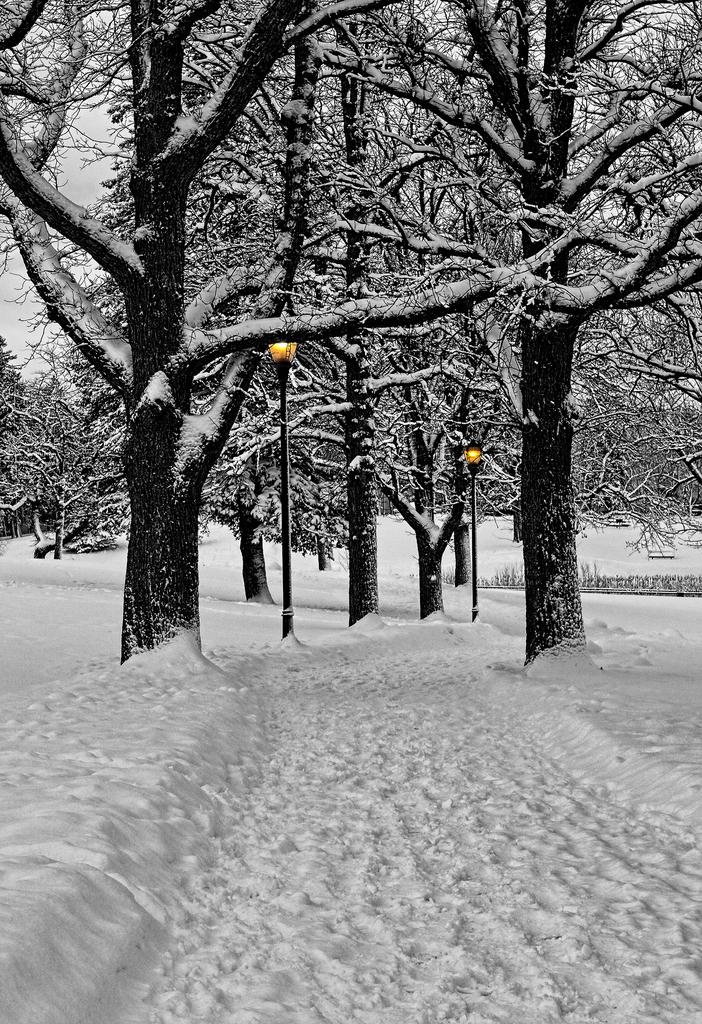What type of weather condition is depicted in the image? There is snow on the surface at the bottom of the image, indicating a snowy or wintry condition. What can be seen in the background of the image? There are trees and light poles in the background of the image. How much sugar is present in the snow in the image? There is no indication of sugar in the snow in the image, as it is a natural snowy condition. 